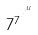Convert formula to latex. <formula><loc_0><loc_0><loc_500><loc_500>7 ^ { 7 ^ { \cdot ^ { \cdot ^ { \cdot ^ { u } } } } }</formula> 